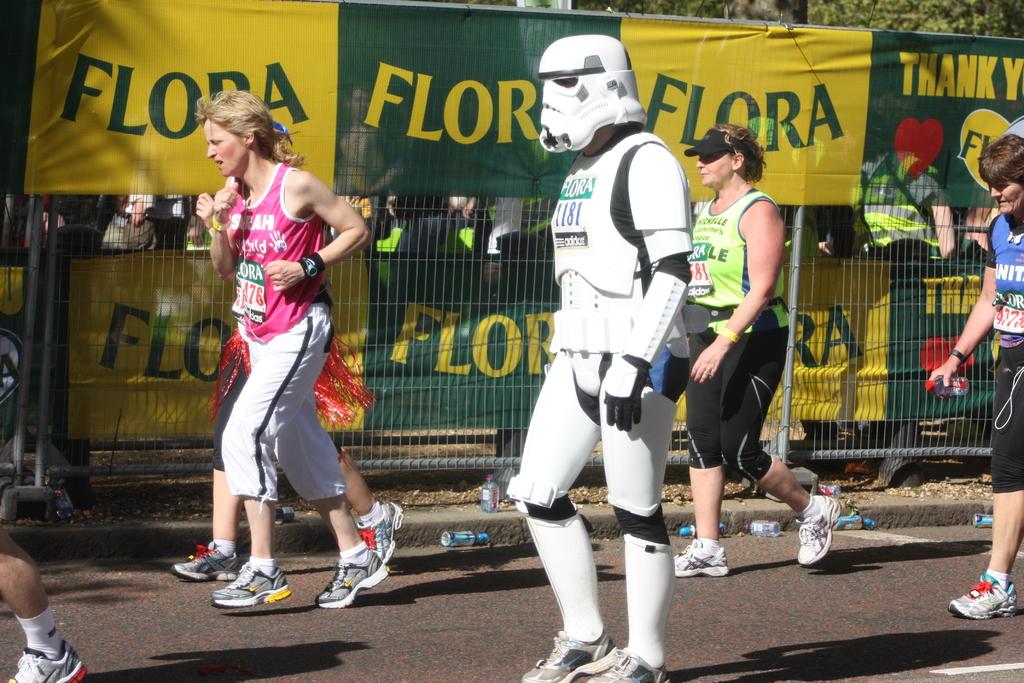What word is written on the flags in the back?
Offer a very short reply. Flora. 